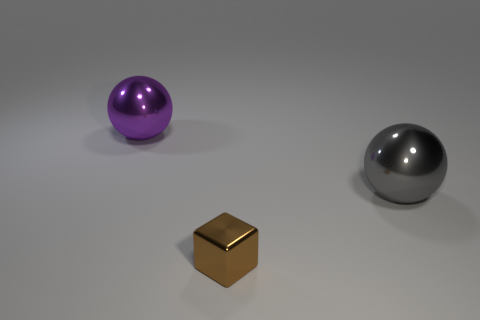There is a ball in front of the purple object; is its size the same as the thing behind the big gray sphere?
Provide a short and direct response. Yes. What number of objects are small cubes or big gray shiny spheres?
Your answer should be compact. 2. There is a purple ball to the left of the big sphere that is on the right side of the tiny brown metal thing; what is it made of?
Keep it short and to the point. Metal. What number of other tiny objects have the same shape as the tiny brown object?
Ensure brevity in your answer.  0. Is there a thing of the same color as the block?
Offer a very short reply. No. How many objects are either large metal things in front of the purple object or tiny brown cubes that are in front of the purple object?
Your response must be concise. 2. Is there a gray shiny thing that is in front of the sphere that is on the right side of the big purple shiny ball?
Offer a very short reply. No. There is a metal thing that is the same size as the purple metal sphere; what shape is it?
Your answer should be very brief. Sphere. How many objects are either large things that are to the left of the gray thing or large purple metallic things?
Make the answer very short. 1. What number of other things are the same material as the brown block?
Provide a succinct answer. 2. 